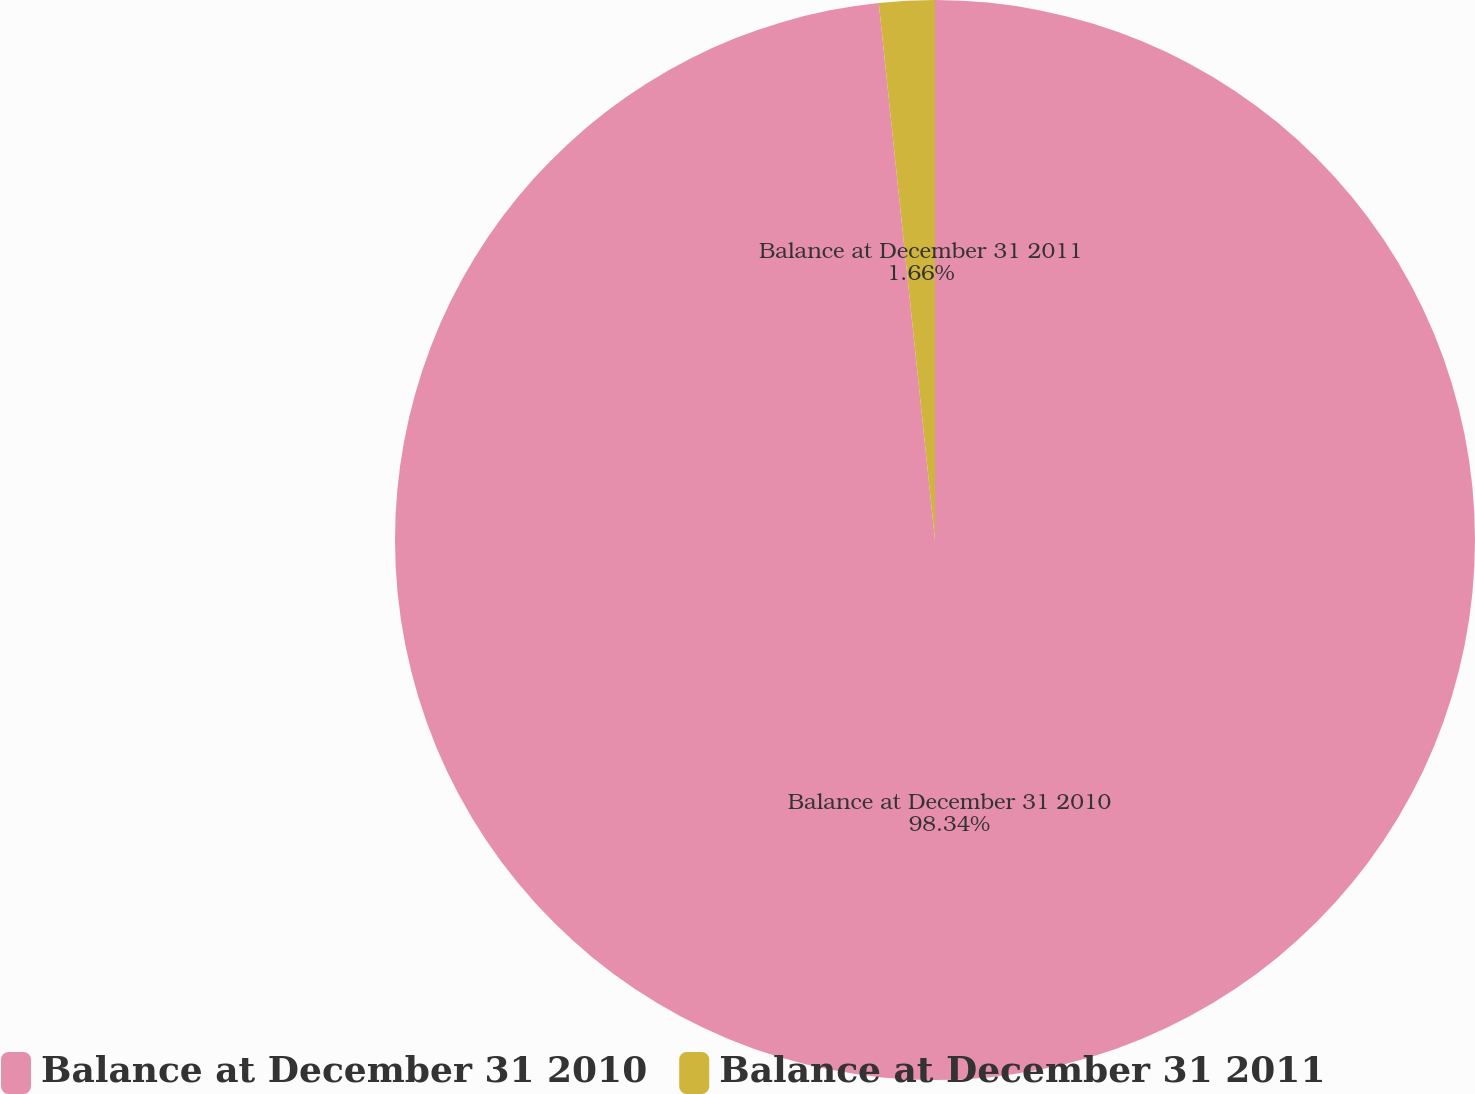Convert chart to OTSL. <chart><loc_0><loc_0><loc_500><loc_500><pie_chart><fcel>Balance at December 31 2010<fcel>Balance at December 31 2011<nl><fcel>98.34%<fcel>1.66%<nl></chart> 